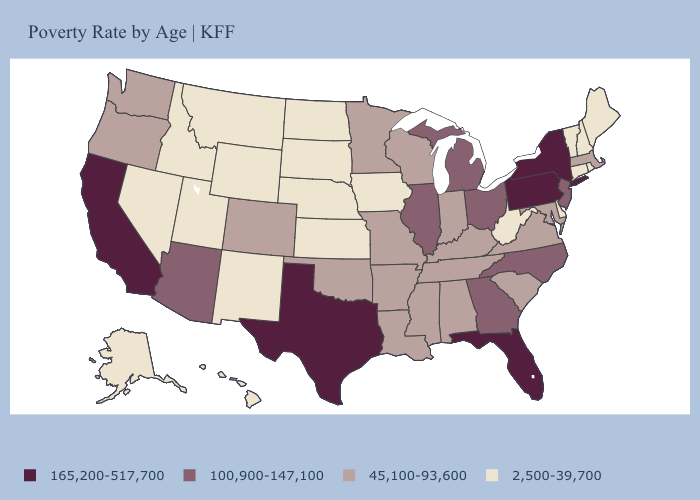Name the states that have a value in the range 100,900-147,100?
Quick response, please. Arizona, Georgia, Illinois, Michigan, New Jersey, North Carolina, Ohio. Does Washington have the highest value in the West?
Write a very short answer. No. How many symbols are there in the legend?
Keep it brief. 4. Name the states that have a value in the range 100,900-147,100?
Give a very brief answer. Arizona, Georgia, Illinois, Michigan, New Jersey, North Carolina, Ohio. Which states have the lowest value in the MidWest?
Answer briefly. Iowa, Kansas, Nebraska, North Dakota, South Dakota. Does Kansas have the highest value in the MidWest?
Short answer required. No. How many symbols are there in the legend?
Concise answer only. 4. What is the lowest value in the MidWest?
Short answer required. 2,500-39,700. What is the value of West Virginia?
Give a very brief answer. 2,500-39,700. Name the states that have a value in the range 100,900-147,100?
Quick response, please. Arizona, Georgia, Illinois, Michigan, New Jersey, North Carolina, Ohio. What is the value of Maryland?
Concise answer only. 45,100-93,600. Does the map have missing data?
Write a very short answer. No. Among the states that border South Carolina , which have the lowest value?
Give a very brief answer. Georgia, North Carolina. Which states have the lowest value in the USA?
Short answer required. Alaska, Connecticut, Delaware, Hawaii, Idaho, Iowa, Kansas, Maine, Montana, Nebraska, Nevada, New Hampshire, New Mexico, North Dakota, Rhode Island, South Dakota, Utah, Vermont, West Virginia, Wyoming. Does South Dakota have the highest value in the MidWest?
Quick response, please. No. 